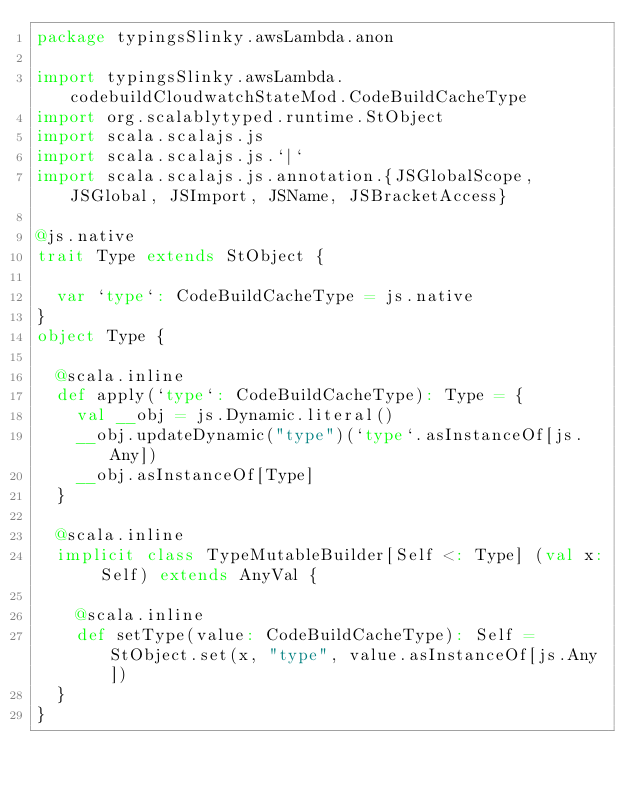Convert code to text. <code><loc_0><loc_0><loc_500><loc_500><_Scala_>package typingsSlinky.awsLambda.anon

import typingsSlinky.awsLambda.codebuildCloudwatchStateMod.CodeBuildCacheType
import org.scalablytyped.runtime.StObject
import scala.scalajs.js
import scala.scalajs.js.`|`
import scala.scalajs.js.annotation.{JSGlobalScope, JSGlobal, JSImport, JSName, JSBracketAccess}

@js.native
trait Type extends StObject {
  
  var `type`: CodeBuildCacheType = js.native
}
object Type {
  
  @scala.inline
  def apply(`type`: CodeBuildCacheType): Type = {
    val __obj = js.Dynamic.literal()
    __obj.updateDynamic("type")(`type`.asInstanceOf[js.Any])
    __obj.asInstanceOf[Type]
  }
  
  @scala.inline
  implicit class TypeMutableBuilder[Self <: Type] (val x: Self) extends AnyVal {
    
    @scala.inline
    def setType(value: CodeBuildCacheType): Self = StObject.set(x, "type", value.asInstanceOf[js.Any])
  }
}
</code> 